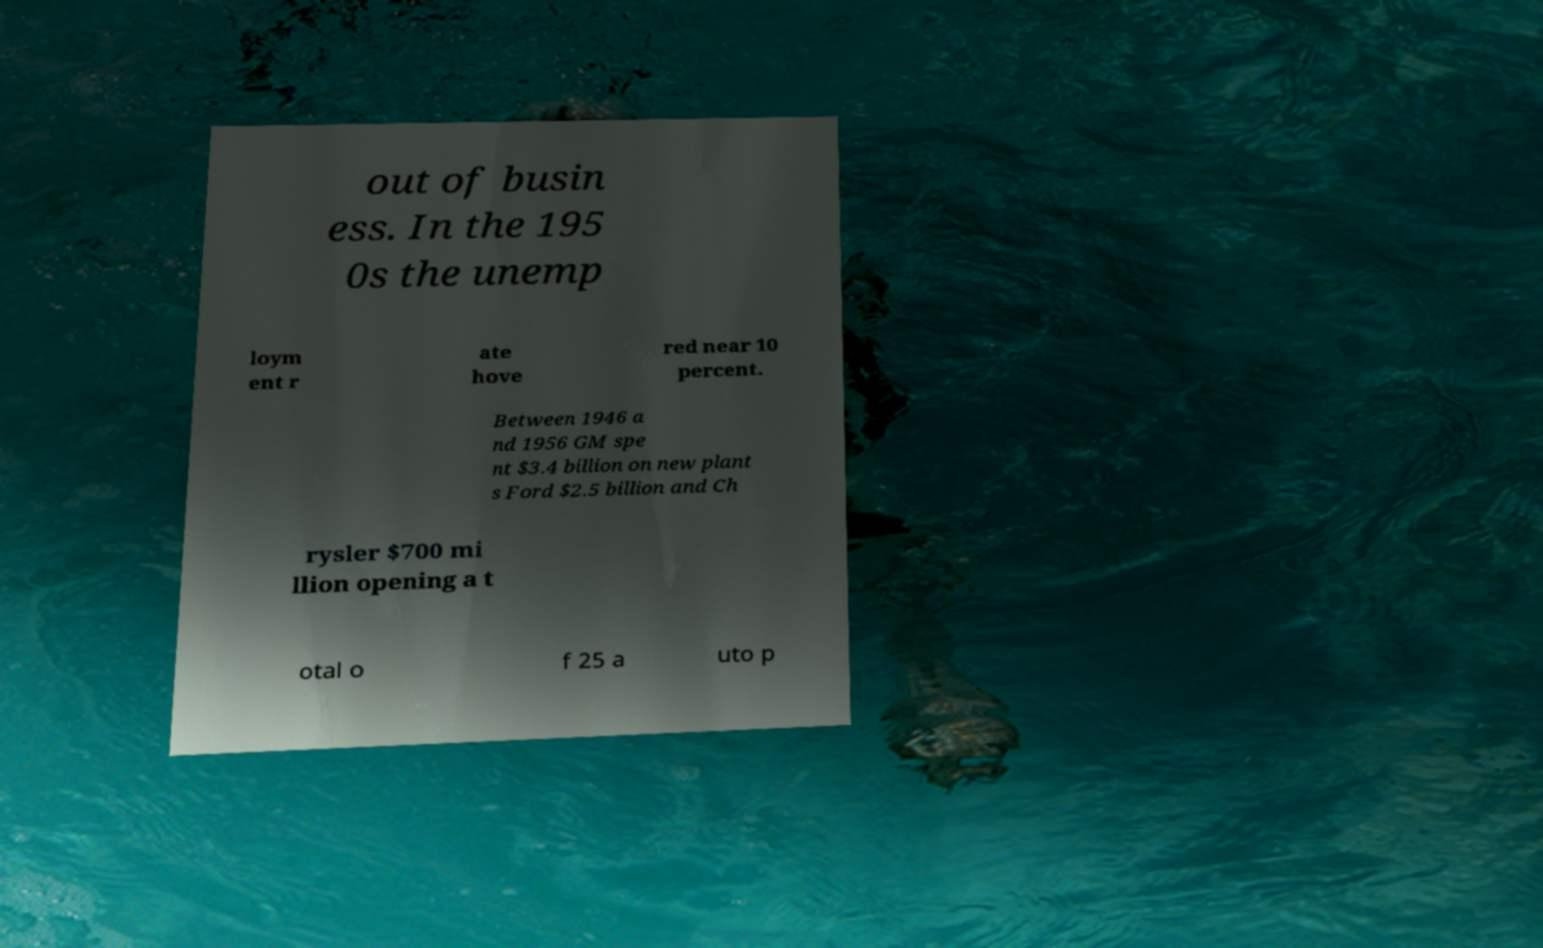For documentation purposes, I need the text within this image transcribed. Could you provide that? out of busin ess. In the 195 0s the unemp loym ent r ate hove red near 10 percent. Between 1946 a nd 1956 GM spe nt $3.4 billion on new plant s Ford $2.5 billion and Ch rysler $700 mi llion opening a t otal o f 25 a uto p 